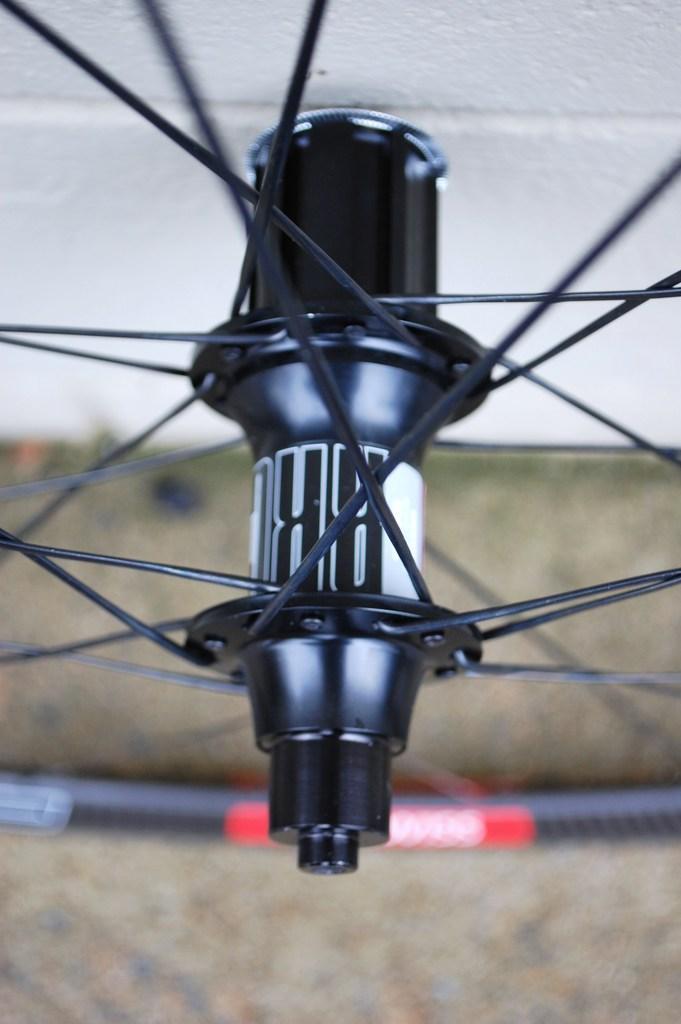How would you summarize this image in a sentence or two? In this image we can see a wheel of a cycle. In the background of the image there is a wall. 